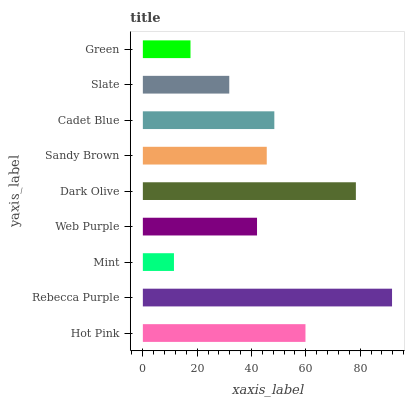Is Mint the minimum?
Answer yes or no. Yes. Is Rebecca Purple the maximum?
Answer yes or no. Yes. Is Rebecca Purple the minimum?
Answer yes or no. No. Is Mint the maximum?
Answer yes or no. No. Is Rebecca Purple greater than Mint?
Answer yes or no. Yes. Is Mint less than Rebecca Purple?
Answer yes or no. Yes. Is Mint greater than Rebecca Purple?
Answer yes or no. No. Is Rebecca Purple less than Mint?
Answer yes or no. No. Is Sandy Brown the high median?
Answer yes or no. Yes. Is Sandy Brown the low median?
Answer yes or no. Yes. Is Hot Pink the high median?
Answer yes or no. No. Is Cadet Blue the low median?
Answer yes or no. No. 